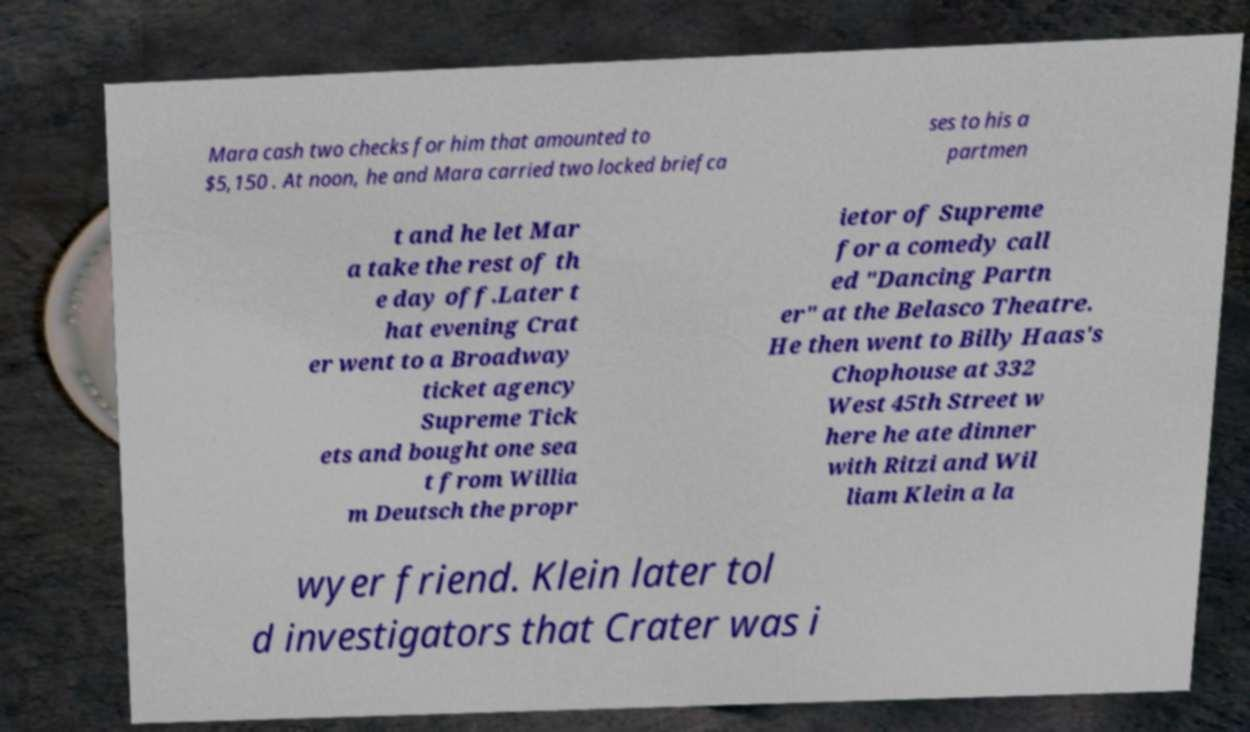There's text embedded in this image that I need extracted. Can you transcribe it verbatim? Mara cash two checks for him that amounted to $5,150 . At noon, he and Mara carried two locked briefca ses to his a partmen t and he let Mar a take the rest of th e day off.Later t hat evening Crat er went to a Broadway ticket agency Supreme Tick ets and bought one sea t from Willia m Deutsch the propr ietor of Supreme for a comedy call ed "Dancing Partn er" at the Belasco Theatre. He then went to Billy Haas's Chophouse at 332 West 45th Street w here he ate dinner with Ritzi and Wil liam Klein a la wyer friend. Klein later tol d investigators that Crater was i 